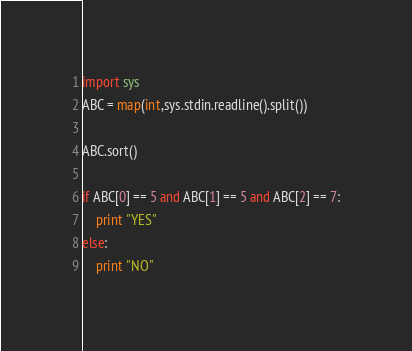Convert code to text. <code><loc_0><loc_0><loc_500><loc_500><_Python_>import sys
ABC = map(int,sys.stdin.readline().split())

ABC.sort()

if ABC[0] == 5 and ABC[1] == 5 and ABC[2] == 7:
    print "YES"
else:
    print "NO"</code> 